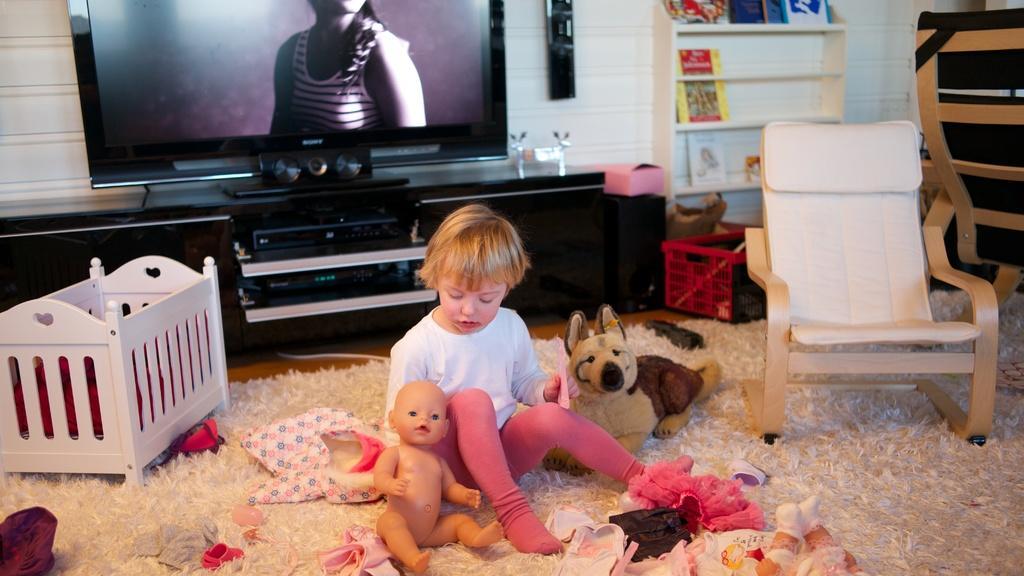How would you summarize this image in a sentence or two? In this image in the middle there is a boy. He is sitting on the mat and there are toys,chair and box. In the background there is television, table, wall, racks and speaker. 